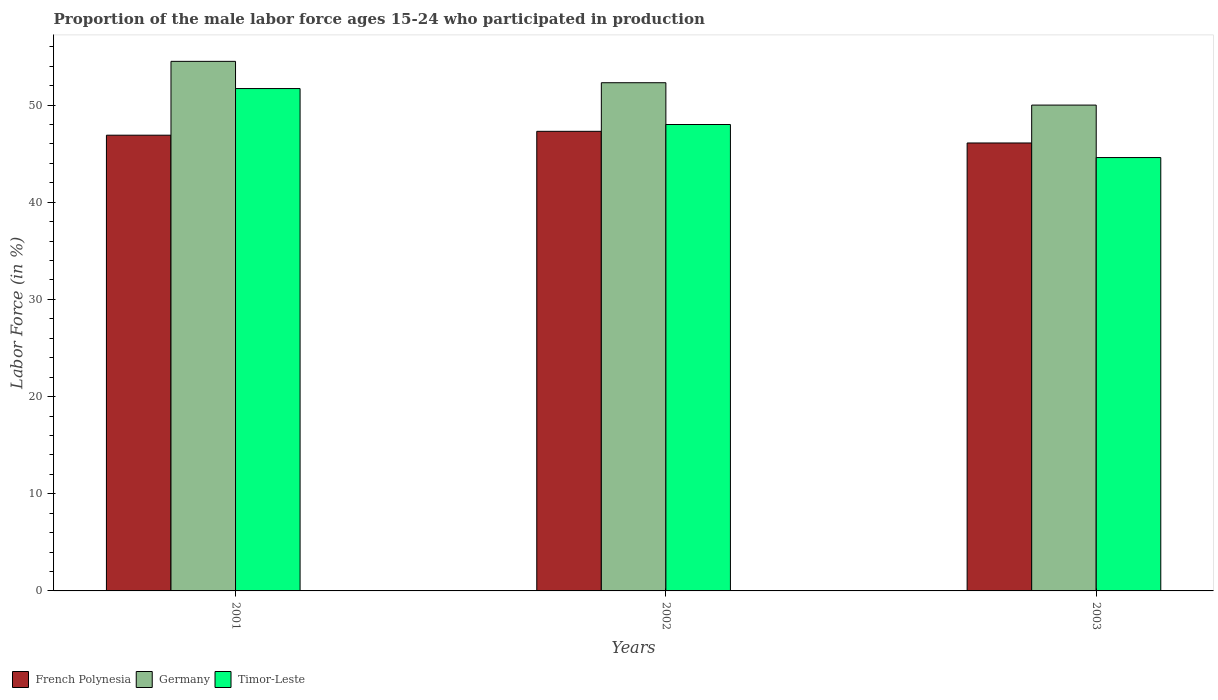Are the number of bars per tick equal to the number of legend labels?
Offer a very short reply. Yes. Are the number of bars on each tick of the X-axis equal?
Your response must be concise. Yes. How many bars are there on the 3rd tick from the right?
Your response must be concise. 3. What is the proportion of the male labor force who participated in production in Timor-Leste in 2002?
Give a very brief answer. 48. Across all years, what is the maximum proportion of the male labor force who participated in production in Timor-Leste?
Keep it short and to the point. 51.7. Across all years, what is the minimum proportion of the male labor force who participated in production in Timor-Leste?
Provide a succinct answer. 44.6. In which year was the proportion of the male labor force who participated in production in French Polynesia minimum?
Your answer should be very brief. 2003. What is the total proportion of the male labor force who participated in production in Timor-Leste in the graph?
Offer a terse response. 144.3. What is the difference between the proportion of the male labor force who participated in production in Germany in 2002 and that in 2003?
Your answer should be very brief. 2.3. What is the difference between the proportion of the male labor force who participated in production in Timor-Leste in 2003 and the proportion of the male labor force who participated in production in Germany in 2001?
Your response must be concise. -9.9. What is the average proportion of the male labor force who participated in production in French Polynesia per year?
Keep it short and to the point. 46.77. In the year 2002, what is the difference between the proportion of the male labor force who participated in production in French Polynesia and proportion of the male labor force who participated in production in Timor-Leste?
Provide a short and direct response. -0.7. What is the ratio of the proportion of the male labor force who participated in production in Germany in 2001 to that in 2003?
Provide a succinct answer. 1.09. What is the difference between the highest and the second highest proportion of the male labor force who participated in production in Germany?
Your answer should be compact. 2.2. In how many years, is the proportion of the male labor force who participated in production in Germany greater than the average proportion of the male labor force who participated in production in Germany taken over all years?
Offer a terse response. 2. What does the 1st bar from the left in 2003 represents?
Make the answer very short. French Polynesia. What does the 2nd bar from the right in 2001 represents?
Make the answer very short. Germany. What is the difference between two consecutive major ticks on the Y-axis?
Ensure brevity in your answer.  10. Where does the legend appear in the graph?
Offer a very short reply. Bottom left. How are the legend labels stacked?
Provide a short and direct response. Horizontal. What is the title of the graph?
Give a very brief answer. Proportion of the male labor force ages 15-24 who participated in production. What is the label or title of the X-axis?
Keep it short and to the point. Years. What is the Labor Force (in %) of French Polynesia in 2001?
Make the answer very short. 46.9. What is the Labor Force (in %) of Germany in 2001?
Offer a very short reply. 54.5. What is the Labor Force (in %) in Timor-Leste in 2001?
Give a very brief answer. 51.7. What is the Labor Force (in %) of French Polynesia in 2002?
Offer a very short reply. 47.3. What is the Labor Force (in %) of Germany in 2002?
Your answer should be compact. 52.3. What is the Labor Force (in %) of Timor-Leste in 2002?
Make the answer very short. 48. What is the Labor Force (in %) of French Polynesia in 2003?
Offer a very short reply. 46.1. What is the Labor Force (in %) in Germany in 2003?
Ensure brevity in your answer.  50. What is the Labor Force (in %) in Timor-Leste in 2003?
Provide a succinct answer. 44.6. Across all years, what is the maximum Labor Force (in %) of French Polynesia?
Offer a very short reply. 47.3. Across all years, what is the maximum Labor Force (in %) of Germany?
Keep it short and to the point. 54.5. Across all years, what is the maximum Labor Force (in %) in Timor-Leste?
Provide a succinct answer. 51.7. Across all years, what is the minimum Labor Force (in %) in French Polynesia?
Give a very brief answer. 46.1. Across all years, what is the minimum Labor Force (in %) in Germany?
Offer a terse response. 50. Across all years, what is the minimum Labor Force (in %) in Timor-Leste?
Make the answer very short. 44.6. What is the total Labor Force (in %) of French Polynesia in the graph?
Offer a terse response. 140.3. What is the total Labor Force (in %) in Germany in the graph?
Offer a terse response. 156.8. What is the total Labor Force (in %) of Timor-Leste in the graph?
Your response must be concise. 144.3. What is the difference between the Labor Force (in %) in French Polynesia in 2001 and that in 2002?
Your answer should be compact. -0.4. What is the difference between the Labor Force (in %) of Germany in 2001 and that in 2002?
Your answer should be compact. 2.2. What is the difference between the Labor Force (in %) in Timor-Leste in 2001 and that in 2002?
Keep it short and to the point. 3.7. What is the difference between the Labor Force (in %) of Germany in 2001 and that in 2003?
Your response must be concise. 4.5. What is the difference between the Labor Force (in %) in Timor-Leste in 2001 and that in 2003?
Your response must be concise. 7.1. What is the difference between the Labor Force (in %) in Germany in 2002 and that in 2003?
Provide a short and direct response. 2.3. What is the difference between the Labor Force (in %) in Timor-Leste in 2002 and that in 2003?
Your answer should be very brief. 3.4. What is the difference between the Labor Force (in %) of French Polynesia in 2001 and the Labor Force (in %) of Germany in 2002?
Your answer should be very brief. -5.4. What is the difference between the Labor Force (in %) in French Polynesia in 2001 and the Labor Force (in %) in Timor-Leste in 2002?
Give a very brief answer. -1.1. What is the difference between the Labor Force (in %) in French Polynesia in 2001 and the Labor Force (in %) in Timor-Leste in 2003?
Your response must be concise. 2.3. What is the difference between the Labor Force (in %) in Germany in 2001 and the Labor Force (in %) in Timor-Leste in 2003?
Provide a short and direct response. 9.9. What is the difference between the Labor Force (in %) in French Polynesia in 2002 and the Labor Force (in %) in Germany in 2003?
Your answer should be very brief. -2.7. What is the difference between the Labor Force (in %) in French Polynesia in 2002 and the Labor Force (in %) in Timor-Leste in 2003?
Make the answer very short. 2.7. What is the average Labor Force (in %) in French Polynesia per year?
Your answer should be very brief. 46.77. What is the average Labor Force (in %) in Germany per year?
Ensure brevity in your answer.  52.27. What is the average Labor Force (in %) in Timor-Leste per year?
Provide a short and direct response. 48.1. In the year 2002, what is the difference between the Labor Force (in %) in French Polynesia and Labor Force (in %) in Timor-Leste?
Provide a short and direct response. -0.7. In the year 2002, what is the difference between the Labor Force (in %) in Germany and Labor Force (in %) in Timor-Leste?
Give a very brief answer. 4.3. In the year 2003, what is the difference between the Labor Force (in %) of French Polynesia and Labor Force (in %) of Germany?
Keep it short and to the point. -3.9. In the year 2003, what is the difference between the Labor Force (in %) of Germany and Labor Force (in %) of Timor-Leste?
Your answer should be compact. 5.4. What is the ratio of the Labor Force (in %) in French Polynesia in 2001 to that in 2002?
Keep it short and to the point. 0.99. What is the ratio of the Labor Force (in %) in Germany in 2001 to that in 2002?
Provide a succinct answer. 1.04. What is the ratio of the Labor Force (in %) in Timor-Leste in 2001 to that in 2002?
Offer a very short reply. 1.08. What is the ratio of the Labor Force (in %) of French Polynesia in 2001 to that in 2003?
Give a very brief answer. 1.02. What is the ratio of the Labor Force (in %) of Germany in 2001 to that in 2003?
Your response must be concise. 1.09. What is the ratio of the Labor Force (in %) in Timor-Leste in 2001 to that in 2003?
Make the answer very short. 1.16. What is the ratio of the Labor Force (in %) in Germany in 2002 to that in 2003?
Provide a short and direct response. 1.05. What is the ratio of the Labor Force (in %) in Timor-Leste in 2002 to that in 2003?
Your response must be concise. 1.08. What is the difference between the highest and the second highest Labor Force (in %) of French Polynesia?
Ensure brevity in your answer.  0.4. What is the difference between the highest and the second highest Labor Force (in %) in Timor-Leste?
Ensure brevity in your answer.  3.7. What is the difference between the highest and the lowest Labor Force (in %) of French Polynesia?
Give a very brief answer. 1.2. 